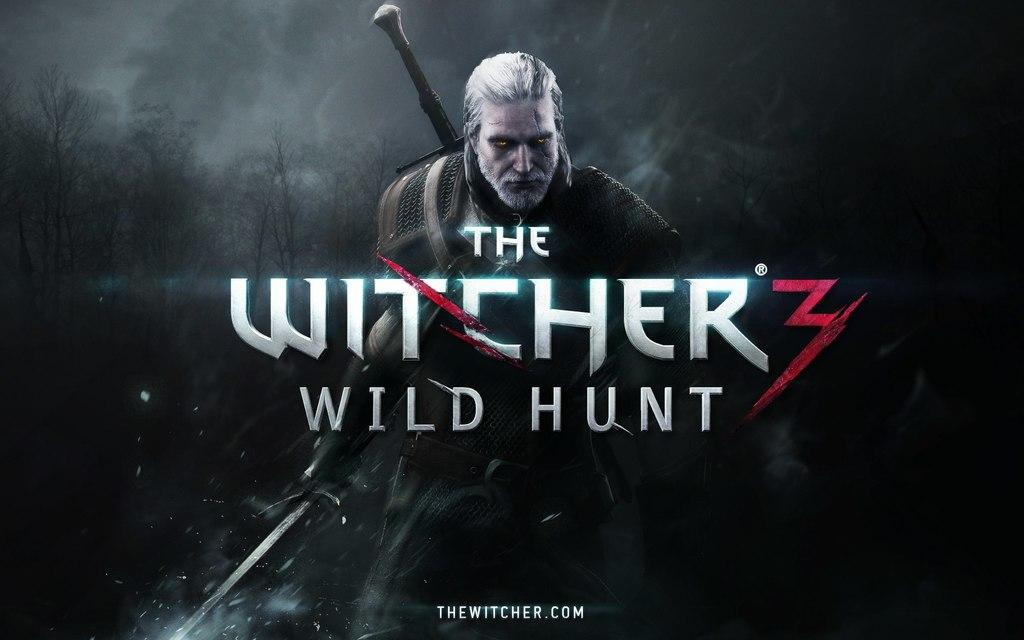<image>
Relay a brief, clear account of the picture shown. A poster of ad of a game called The Witcher's wild hunt, it looks frightening. 